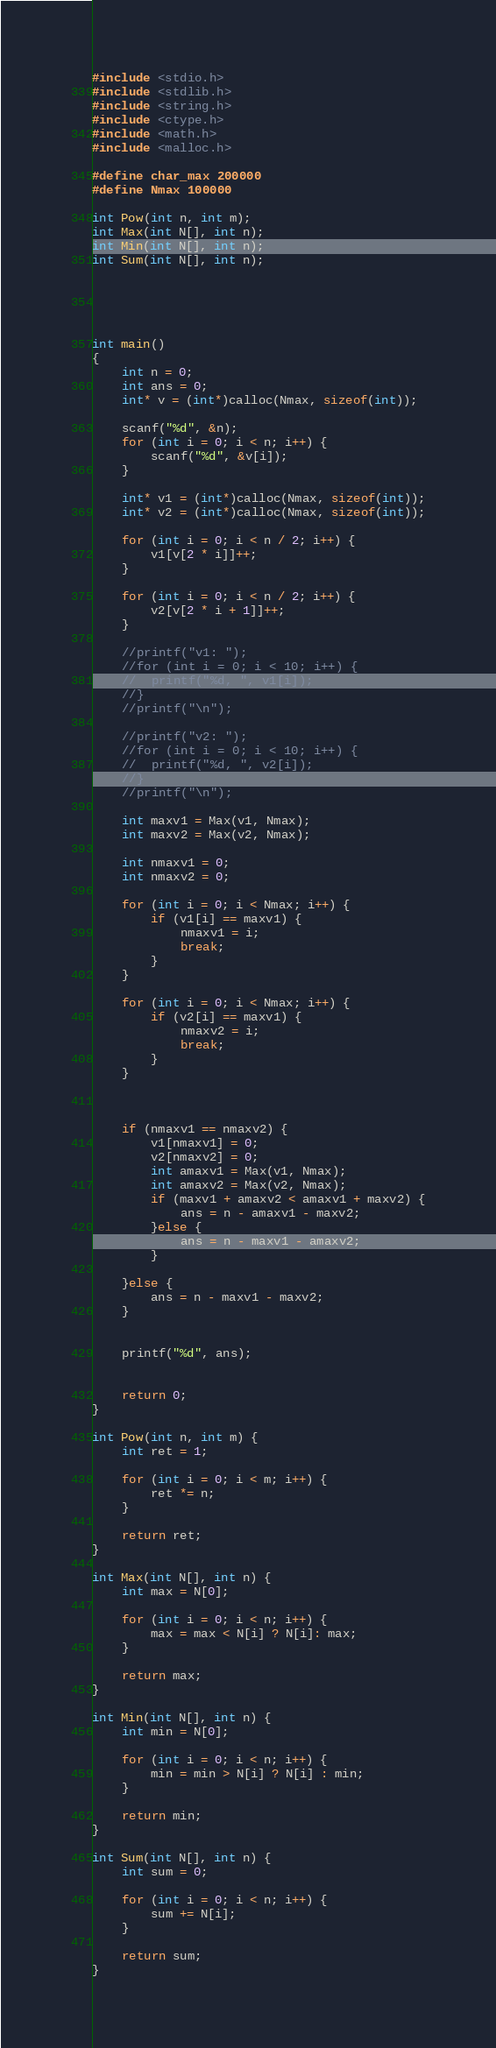Convert code to text. <code><loc_0><loc_0><loc_500><loc_500><_C_>#include <stdio.h>
#include <stdlib.h>
#include <string.h>
#include <ctype.h>
#include <math.h>
#include <malloc.h>

#define char_max 200000
#define Nmax 100000

int Pow(int n, int m);
int Max(int N[], int n);
int Min(int N[], int n);
int Sum(int N[], int n);





int main()
{
	int n = 0;
	int ans = 0;
	int* v = (int*)calloc(Nmax, sizeof(int));

	scanf("%d", &n);
	for (int i = 0; i < n; i++) {
		scanf("%d", &v[i]);
	}

	int* v1 = (int*)calloc(Nmax, sizeof(int));
	int* v2 = (int*)calloc(Nmax, sizeof(int));

	for (int i = 0; i < n / 2; i++) {
		v1[v[2 * i]]++;
	}

	for (int i = 0; i < n / 2; i++) {
		v2[v[2 * i + 1]]++;
	}
	
	//printf("v1: ");
	//for (int i = 0; i < 10; i++) {
	//	printf("%d, ", v1[i]);
	//}
	//printf("\n");

	//printf("v2: ");
	//for (int i = 0; i < 10; i++) {
	//	printf("%d, ", v2[i]);
	//}
	//printf("\n");

	int maxv1 = Max(v1, Nmax);
	int maxv2 = Max(v2, Nmax);

	int nmaxv1 = 0;
	int nmaxv2 = 0;

	for (int i = 0; i < Nmax; i++) {
		if (v1[i] == maxv1) {
			nmaxv1 = i;
			break;
		}
	}

	for (int i = 0; i < Nmax; i++) {
		if (v2[i] == maxv1) {
			nmaxv2 = i;
			break;
		}
	}

	
	
	if (nmaxv1 == nmaxv2) {
		v1[nmaxv1] = 0;
		v2[nmaxv2] = 0;
		int amaxv1 = Max(v1, Nmax);
		int amaxv2 = Max(v2, Nmax);
		if (maxv1 + amaxv2 < amaxv1 + maxv2) {
			ans = n - amaxv1 - maxv2;
		}else {
			ans = n - maxv1 - amaxv2;
		}

	}else {
		ans = n - maxv1 - maxv2;
	}
	

	printf("%d", ans);


	return 0;
}

int Pow(int n, int m) {
	int ret = 1;

	for (int i = 0; i < m; i++) {
		ret *= n;
	}

	return ret;
}

int Max(int N[], int n) {
	int max = N[0];

	for (int i = 0; i < n; i++) {
		max = max < N[i] ? N[i]: max;
	}

	return max;
}

int Min(int N[], int n) {
	int min = N[0];

	for (int i = 0; i < n; i++) {
		min = min > N[i] ? N[i] : min;
	}

	return min;
}

int Sum(int N[], int n) {
	int sum = 0;

	for (int i = 0; i < n; i++) {
		sum += N[i];
	}

	return sum;
}</code> 